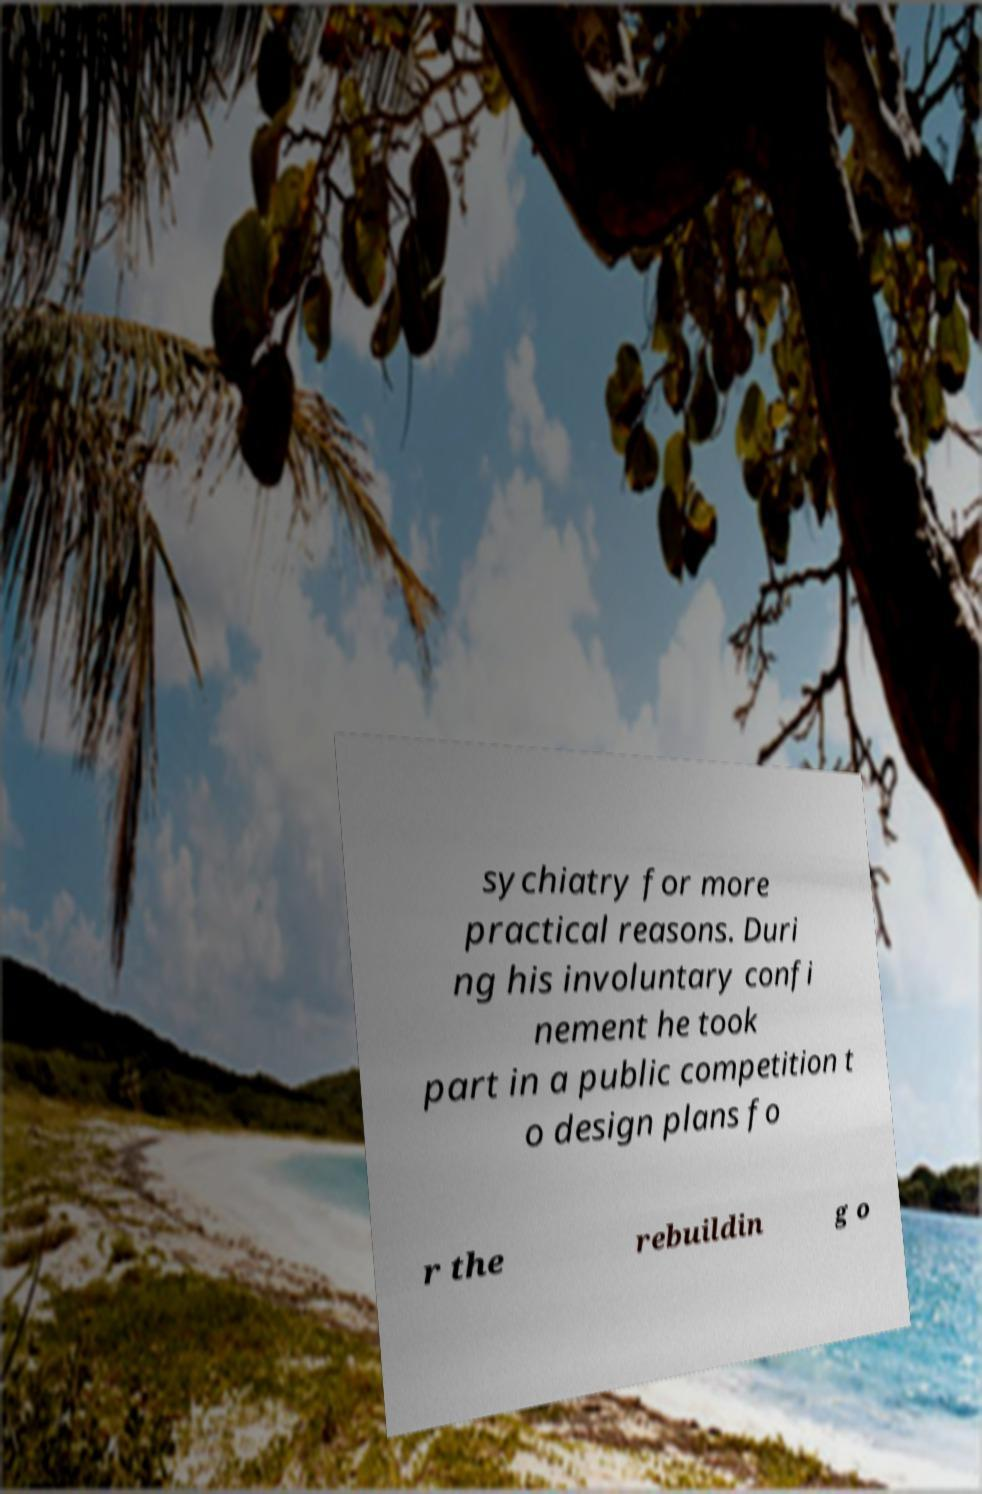Can you accurately transcribe the text from the provided image for me? sychiatry for more practical reasons. Duri ng his involuntary confi nement he took part in a public competition t o design plans fo r the rebuildin g o 